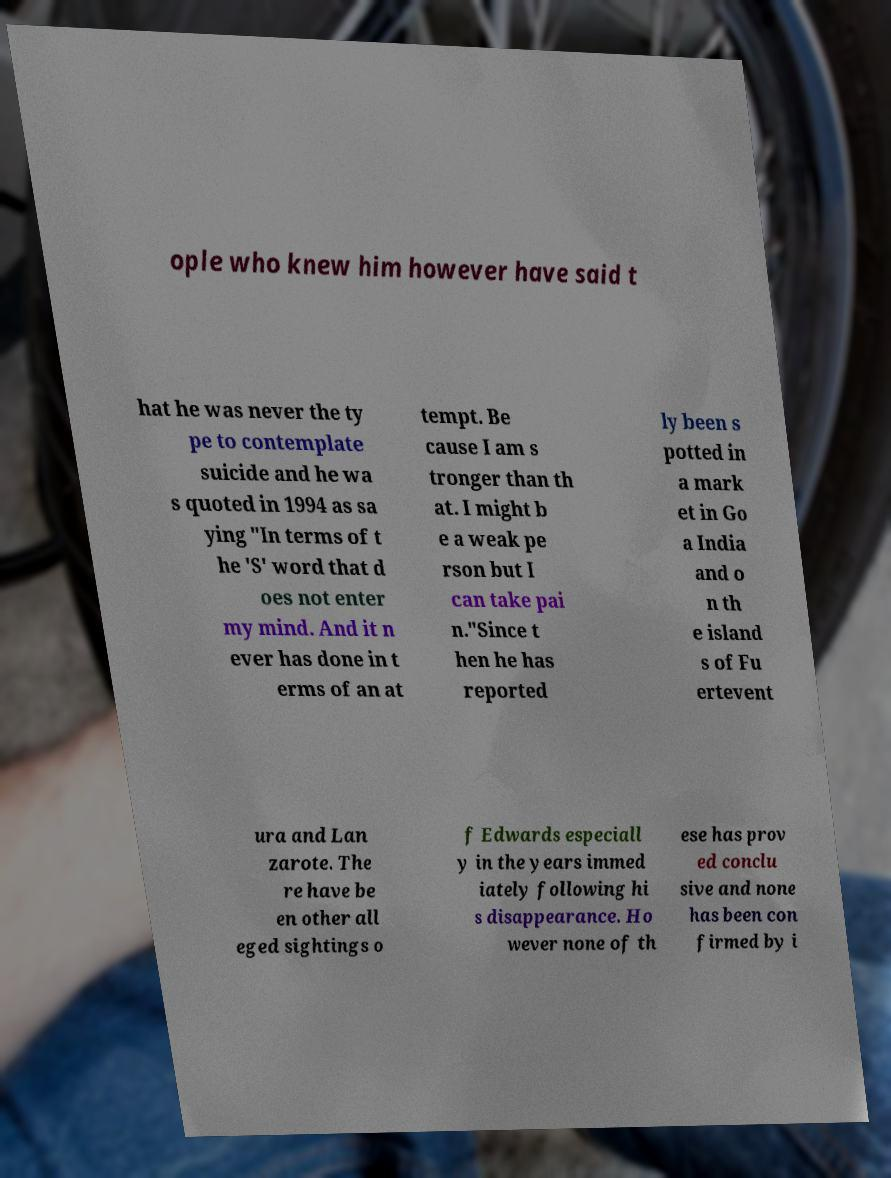There's text embedded in this image that I need extracted. Can you transcribe it verbatim? ople who knew him however have said t hat he was never the ty pe to contemplate suicide and he wa s quoted in 1994 as sa ying "In terms of t he 'S' word that d oes not enter my mind. And it n ever has done in t erms of an at tempt. Be cause I am s tronger than th at. I might b e a weak pe rson but I can take pai n."Since t hen he has reported ly been s potted in a mark et in Go a India and o n th e island s of Fu ertevent ura and Lan zarote. The re have be en other all eged sightings o f Edwards especiall y in the years immed iately following hi s disappearance. Ho wever none of th ese has prov ed conclu sive and none has been con firmed by i 